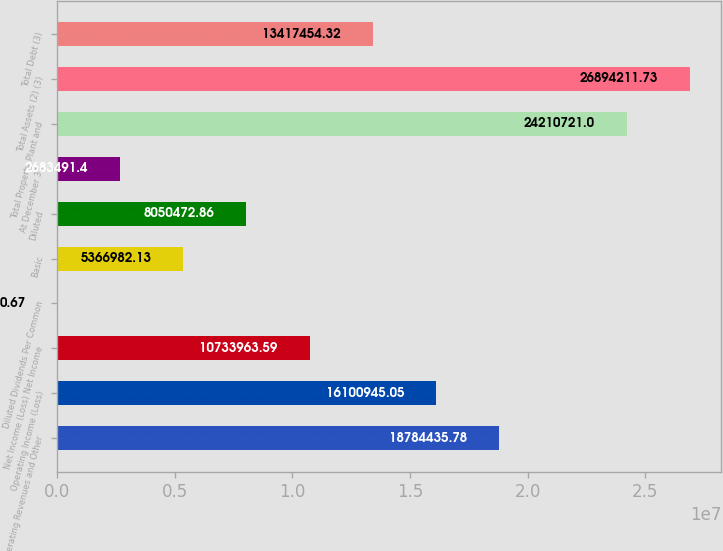Convert chart. <chart><loc_0><loc_0><loc_500><loc_500><bar_chart><fcel>Operating Revenues and Other<fcel>Operating Income (Loss)<fcel>Net Income (Loss) Net Income<fcel>Diluted Dividends Per Common<fcel>Basic<fcel>Diluted<fcel>At December 31<fcel>Total Property Plant and<fcel>Total Assets (2) (3)<fcel>Total Debt (3)<nl><fcel>1.87844e+07<fcel>1.61009e+07<fcel>1.0734e+07<fcel>0.67<fcel>5.36698e+06<fcel>8.05047e+06<fcel>2.68349e+06<fcel>2.42107e+07<fcel>2.68942e+07<fcel>1.34175e+07<nl></chart> 